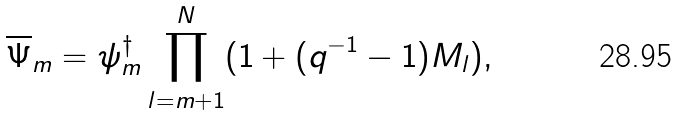Convert formula to latex. <formula><loc_0><loc_0><loc_500><loc_500>\overline { \Psi } _ { m } = \psi _ { m } ^ { \dagger } \prod _ { l = m + 1 } ^ { N } ( 1 + ( q ^ { - 1 } - 1 ) M _ { l } ) ,</formula> 